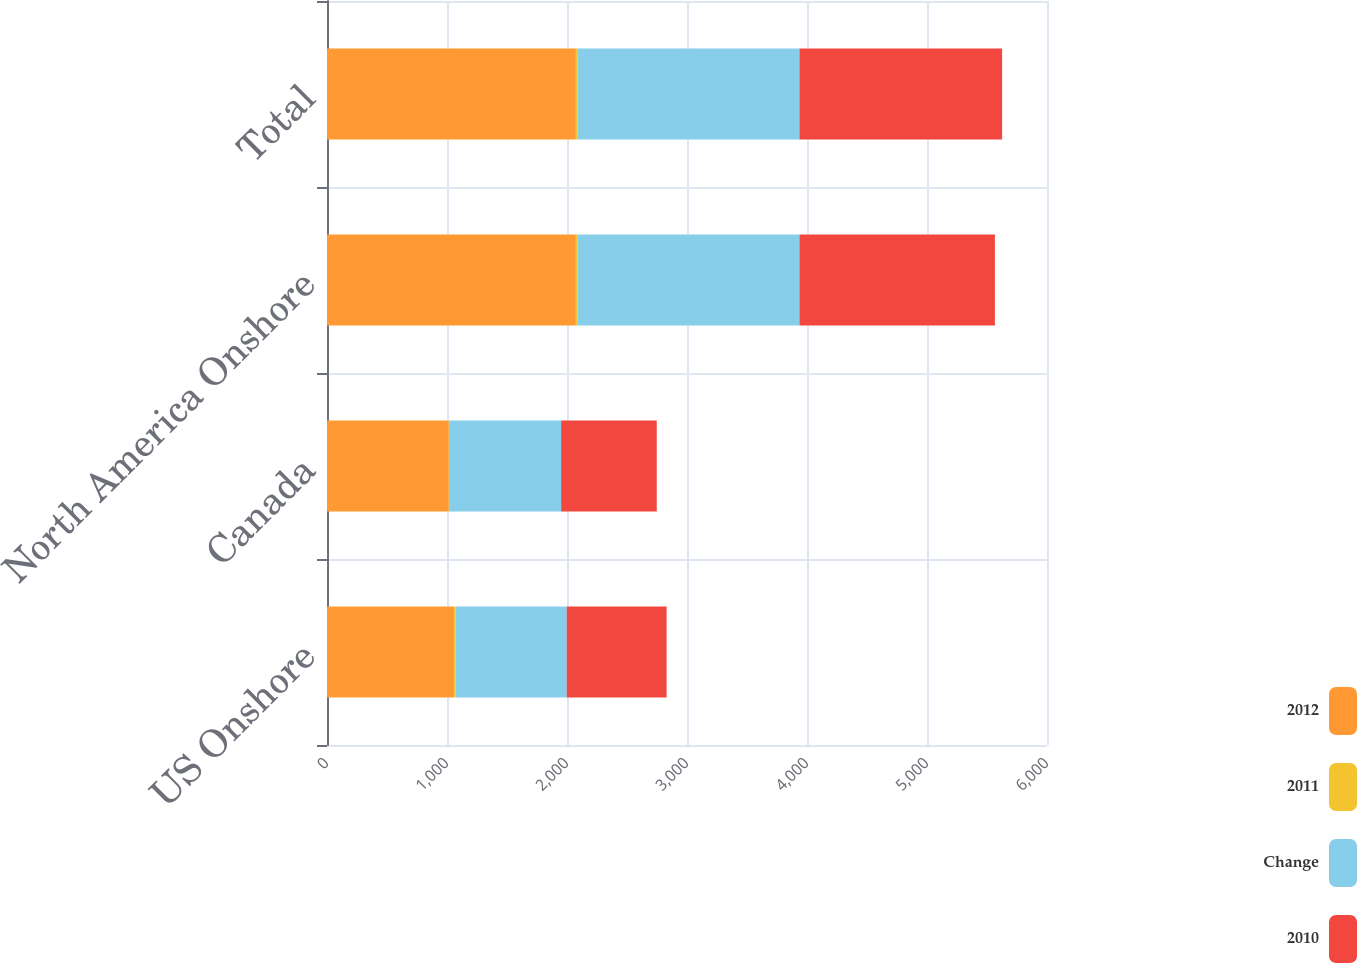Convert chart to OTSL. <chart><loc_0><loc_0><loc_500><loc_500><stacked_bar_chart><ecel><fcel>US Onshore<fcel>Canada<fcel>North America Onshore<fcel>Total<nl><fcel>2012<fcel>1059<fcel>1015<fcel>2074<fcel>2074<nl><fcel>2011<fcel>14<fcel>10<fcel>12<fcel>12<nl><fcel>Change<fcel>925<fcel>926<fcel>1851<fcel>1851<nl><fcel>2010<fcel>832<fcel>797<fcel>1629<fcel>1689<nl></chart> 